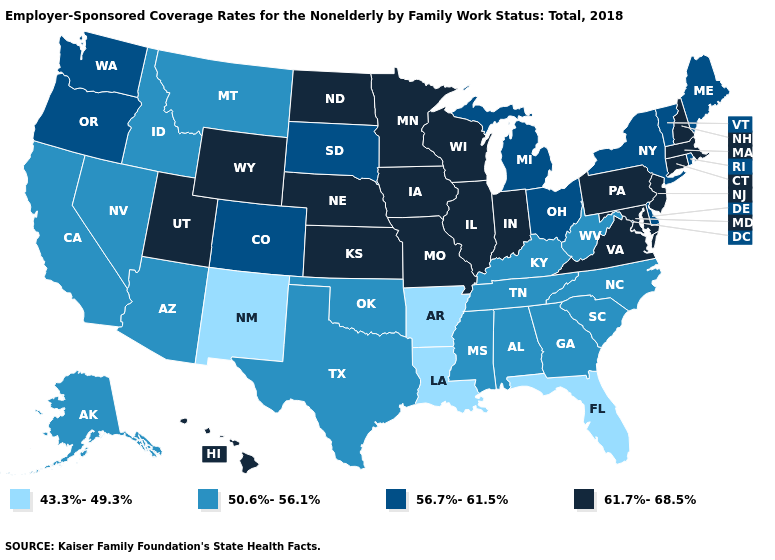What is the highest value in the USA?
Answer briefly. 61.7%-68.5%. What is the lowest value in the USA?
Write a very short answer. 43.3%-49.3%. Name the states that have a value in the range 61.7%-68.5%?
Answer briefly. Connecticut, Hawaii, Illinois, Indiana, Iowa, Kansas, Maryland, Massachusetts, Minnesota, Missouri, Nebraska, New Hampshire, New Jersey, North Dakota, Pennsylvania, Utah, Virginia, Wisconsin, Wyoming. Among the states that border Missouri , which have the highest value?
Write a very short answer. Illinois, Iowa, Kansas, Nebraska. What is the value of Alabama?
Give a very brief answer. 50.6%-56.1%. Among the states that border Washington , does Idaho have the lowest value?
Answer briefly. Yes. What is the value of Kansas?
Answer briefly. 61.7%-68.5%. Is the legend a continuous bar?
Quick response, please. No. Does Illinois have the lowest value in the MidWest?
Short answer required. No. Is the legend a continuous bar?
Keep it brief. No. Which states hav the highest value in the MidWest?
Write a very short answer. Illinois, Indiana, Iowa, Kansas, Minnesota, Missouri, Nebraska, North Dakota, Wisconsin. Name the states that have a value in the range 43.3%-49.3%?
Answer briefly. Arkansas, Florida, Louisiana, New Mexico. Name the states that have a value in the range 43.3%-49.3%?
Be succinct. Arkansas, Florida, Louisiana, New Mexico. Name the states that have a value in the range 50.6%-56.1%?
Be succinct. Alabama, Alaska, Arizona, California, Georgia, Idaho, Kentucky, Mississippi, Montana, Nevada, North Carolina, Oklahoma, South Carolina, Tennessee, Texas, West Virginia. Among the states that border New Jersey , which have the highest value?
Write a very short answer. Pennsylvania. 